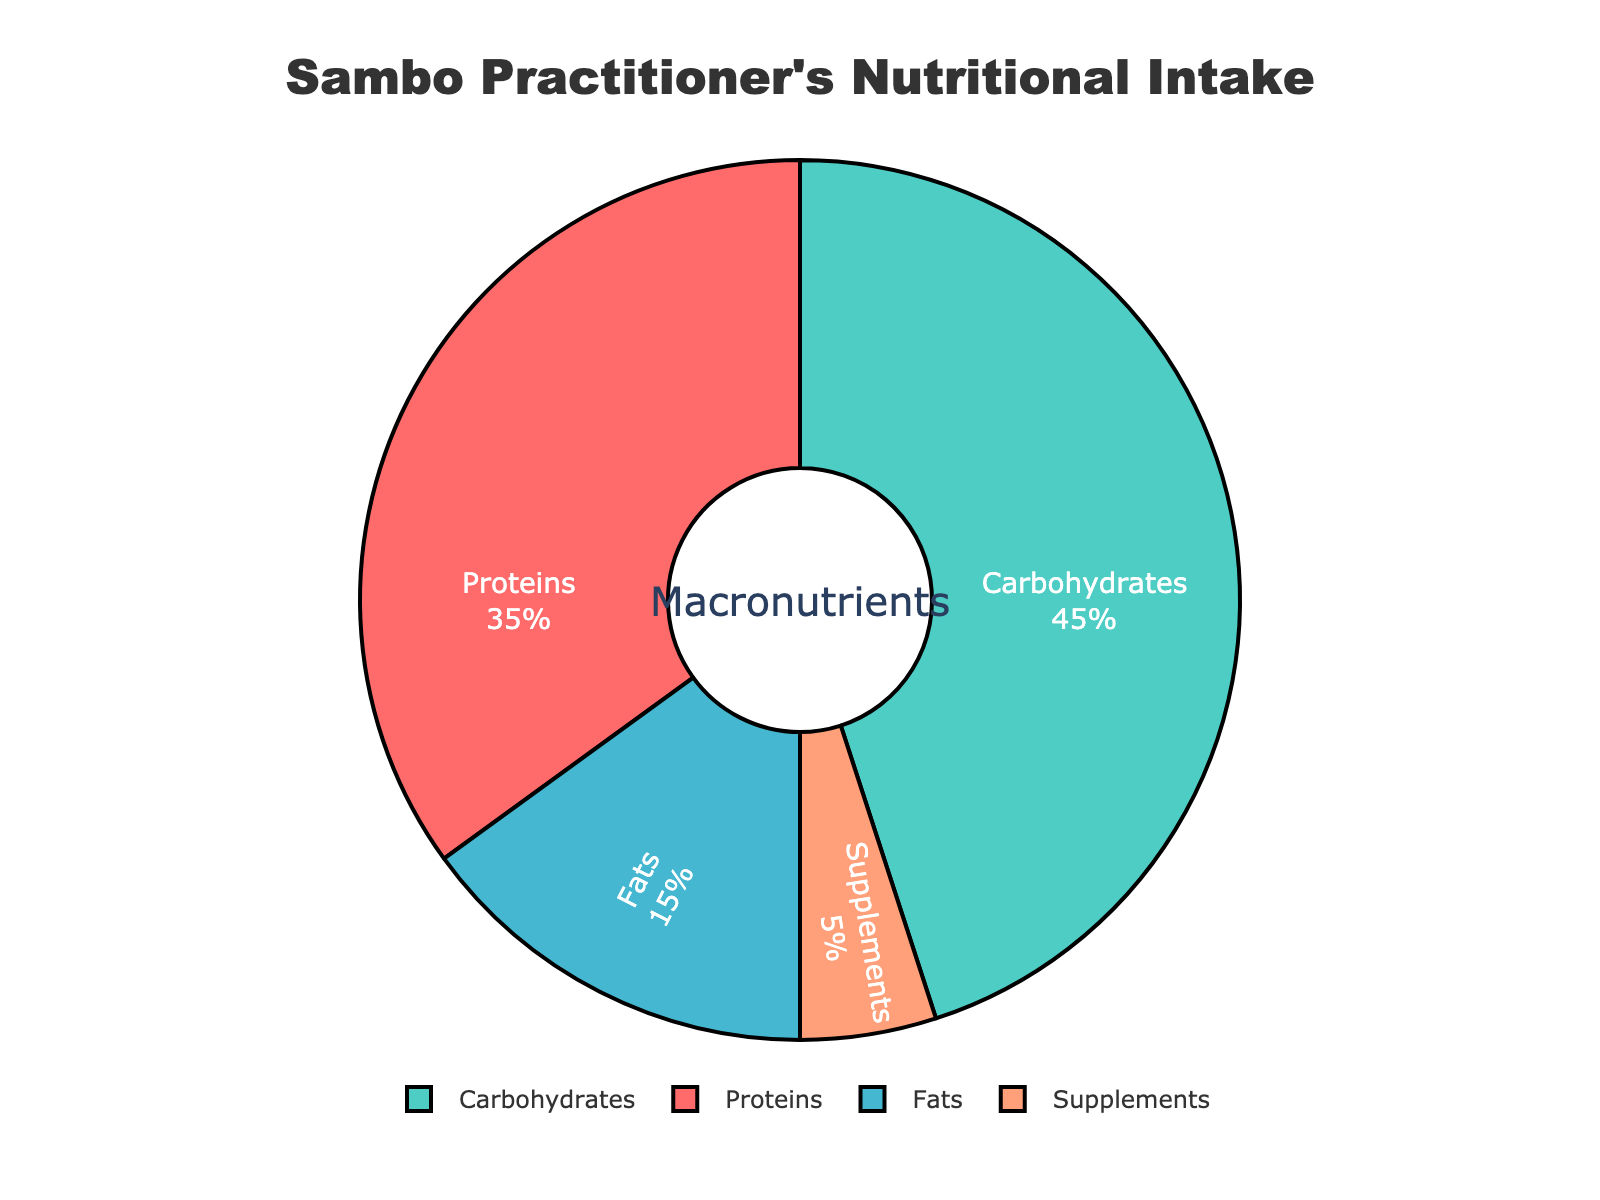What percentage of a sambo practitioner's nutritional intake is made up of proteins and fats combined? To find the combined percentage of proteins and fats, add the percentage of proteins (35%) and fats (15%). Therefore, 35% + 15% = 50%.
Answer: 50% Which macronutrient category has the highest percentage? By looking at the pie chart, the segment with the largest area represents carbohydrates, with a percentage of 45%.
Answer: Carbohydrates Are proteins and supplements together more or less than carbohydrates? Add the percentage of proteins (35%) and supplements (5%), which is 35% + 5% = 40%. Compare this with carbohydrates at 45%. Hence, 40% is less than 45%.
Answer: Less Which macronutrient has the smallest representation in the nutritional intake? By examining the smallest segment in the pie chart, it can be observed that supplements have the least percentage at 5%.
Answer: Supplements Is the percentage of fats smaller than the sum of proteins and carbohydrates? Add the percentage of proteins (35%) and carbohydrates (45%), which is 35% + 45% = 80%. Compare this sum with the percentage of fats (15%). Therefore, fats (15%) is significantly less than 80%.
Answer: Yes What is the difference between the percentage of carbohydrates and fats? Subtract the percentage of fats (15%) from carbohydrates (45%). Therefore, 45% - 15% = 30%.
Answer: 30% What visual features indicate the most significant macronutrient in the pie chart? The largest segment in the pie chart, which is shaded in green, corresponds to the macronutrient with the highest percentage, which is carbohydrates at 45%.
Answer: The largest segment (green, 45%) By how much do proteins exceed fats in percentage terms? Subtract the percentage of fats (15%) from proteins (35%). Therefore, 35% - 15% = 20%.
Answer: 20% What can be inferred about the intake of supplements in comparison to proteins? Compare the percentage of supplements (5%) and proteins (35%), and since 5% is much smaller than 35%, it can be inferred that protein intake is significantly higher.
Answer: Protein intake is significantly higher 